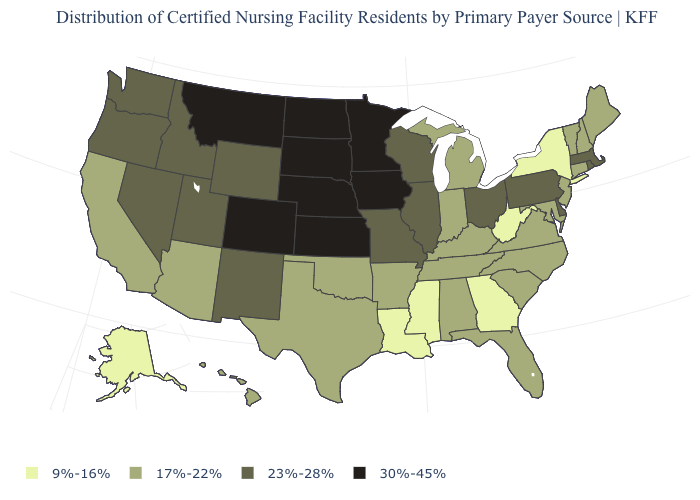Which states have the highest value in the USA?
Concise answer only. Colorado, Iowa, Kansas, Minnesota, Montana, Nebraska, North Dakota, South Dakota. What is the value of California?
Keep it brief. 17%-22%. What is the value of Rhode Island?
Write a very short answer. 23%-28%. What is the value of Washington?
Write a very short answer. 23%-28%. Does the map have missing data?
Short answer required. No. What is the lowest value in the USA?
Concise answer only. 9%-16%. What is the lowest value in the USA?
Keep it brief. 9%-16%. Does the first symbol in the legend represent the smallest category?
Be succinct. Yes. What is the value of Alaska?
Concise answer only. 9%-16%. Name the states that have a value in the range 17%-22%?
Be succinct. Alabama, Arizona, Arkansas, California, Connecticut, Florida, Hawaii, Indiana, Kentucky, Maine, Maryland, Michigan, New Hampshire, New Jersey, North Carolina, Oklahoma, South Carolina, Tennessee, Texas, Vermont, Virginia. Does South Dakota have the lowest value in the USA?
Answer briefly. No. Name the states that have a value in the range 30%-45%?
Keep it brief. Colorado, Iowa, Kansas, Minnesota, Montana, Nebraska, North Dakota, South Dakota. Is the legend a continuous bar?
Keep it brief. No. Among the states that border Texas , which have the highest value?
Quick response, please. New Mexico. 